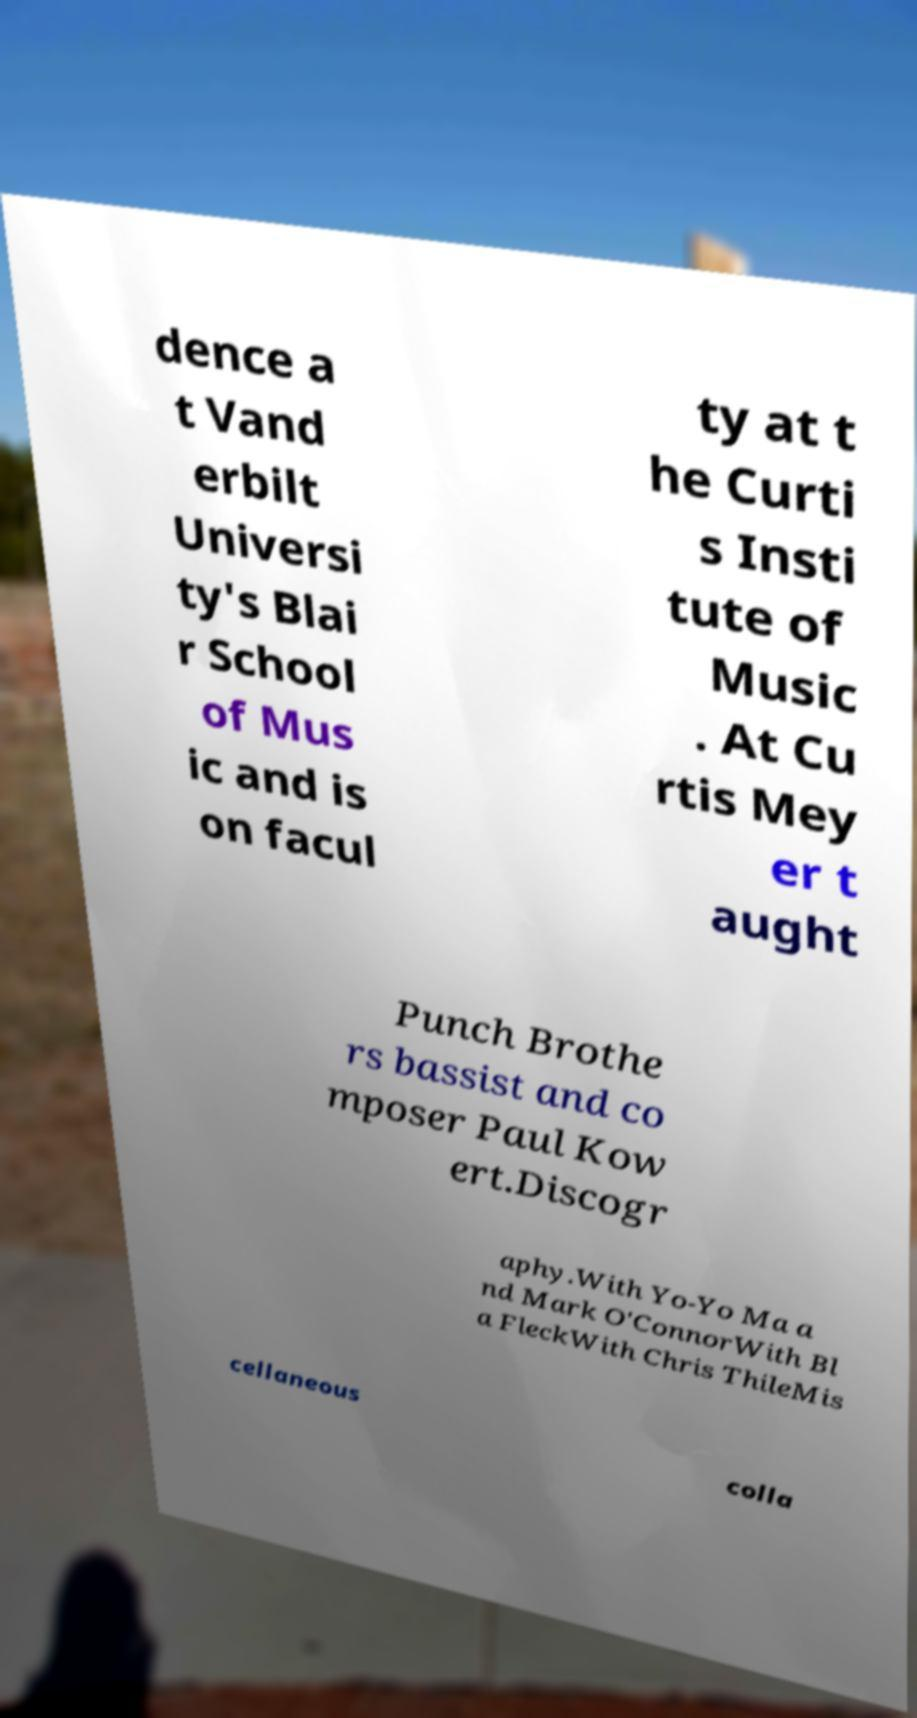For documentation purposes, I need the text within this image transcribed. Could you provide that? dence a t Vand erbilt Universi ty's Blai r School of Mus ic and is on facul ty at t he Curti s Insti tute of Music . At Cu rtis Mey er t aught Punch Brothe rs bassist and co mposer Paul Kow ert.Discogr aphy.With Yo-Yo Ma a nd Mark O'ConnorWith Bl a FleckWith Chris ThileMis cellaneous colla 